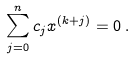<formula> <loc_0><loc_0><loc_500><loc_500>\sum _ { j = 0 } ^ { n } c _ { j } x ^ { ( k + j ) } = 0 \, .</formula> 